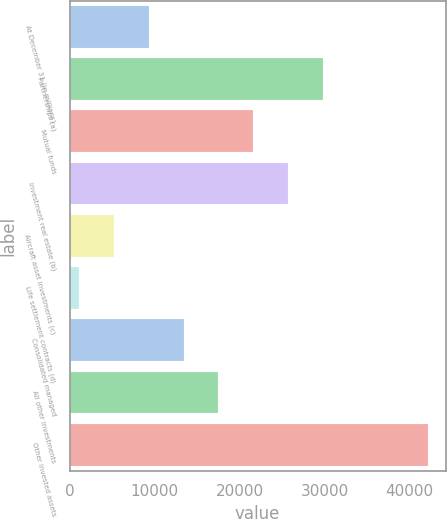<chart> <loc_0><loc_0><loc_500><loc_500><bar_chart><fcel>At December 31 (in millions)<fcel>Partnerships (a)<fcel>Mutual funds<fcel>Investment real estate (b)<fcel>Aircraft asset investments (c)<fcel>Life settlement contracts (d)<fcel>Consolidated managed<fcel>All other investments<fcel>Other invested assets<nl><fcel>9294.2<fcel>29804.7<fcel>21600.5<fcel>25702.6<fcel>5192.1<fcel>1090<fcel>13396.3<fcel>17498.4<fcel>42111<nl></chart> 